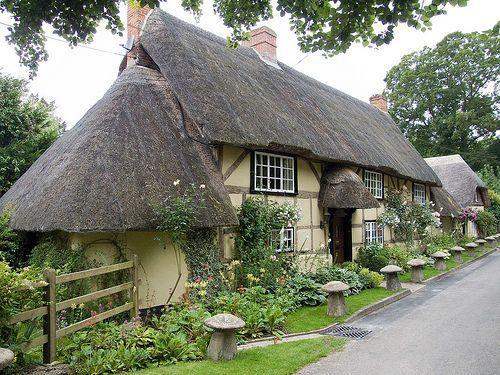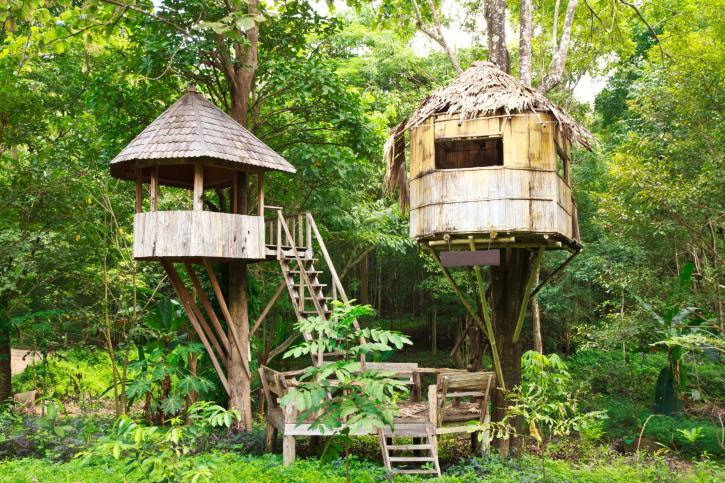The first image is the image on the left, the second image is the image on the right. Examine the images to the left and right. Is the description "An outdoor ladder leads up to a structure in one of the images." accurate? Answer yes or no. Yes. 